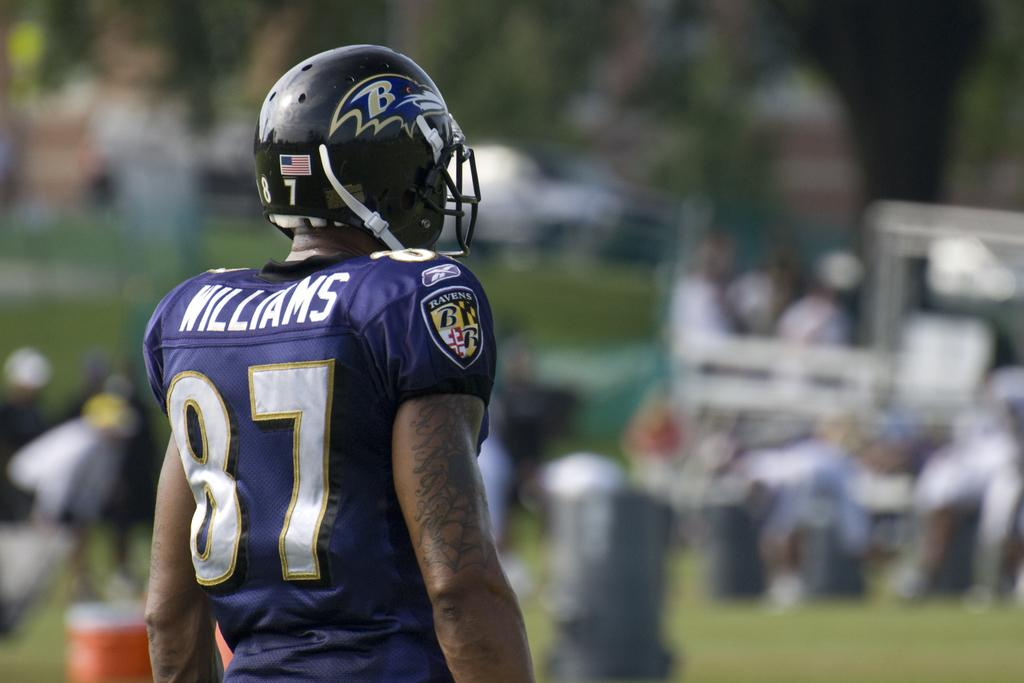Who is present in the image? There is a man in the image. What is the man wearing on his upper body? The man is wearing a blue t-shirt. What is the man wearing on his head? The man is wearing a black helmet. Where is the man standing in the image? The man is standing on a path. What can be seen in front of the man in the image? There are blurred items in front of the man. How many brothers does the man have in the image? There is no information about the man's brothers in the image. 